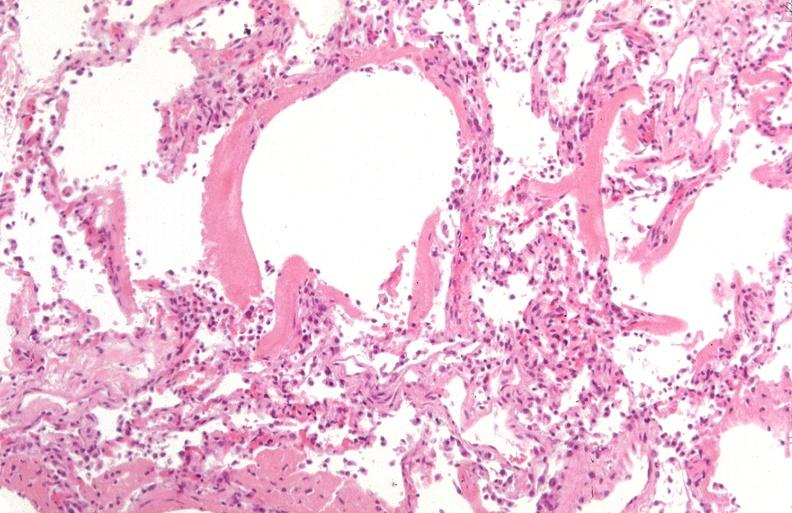s respiratory present?
Answer the question using a single word or phrase. Yes 